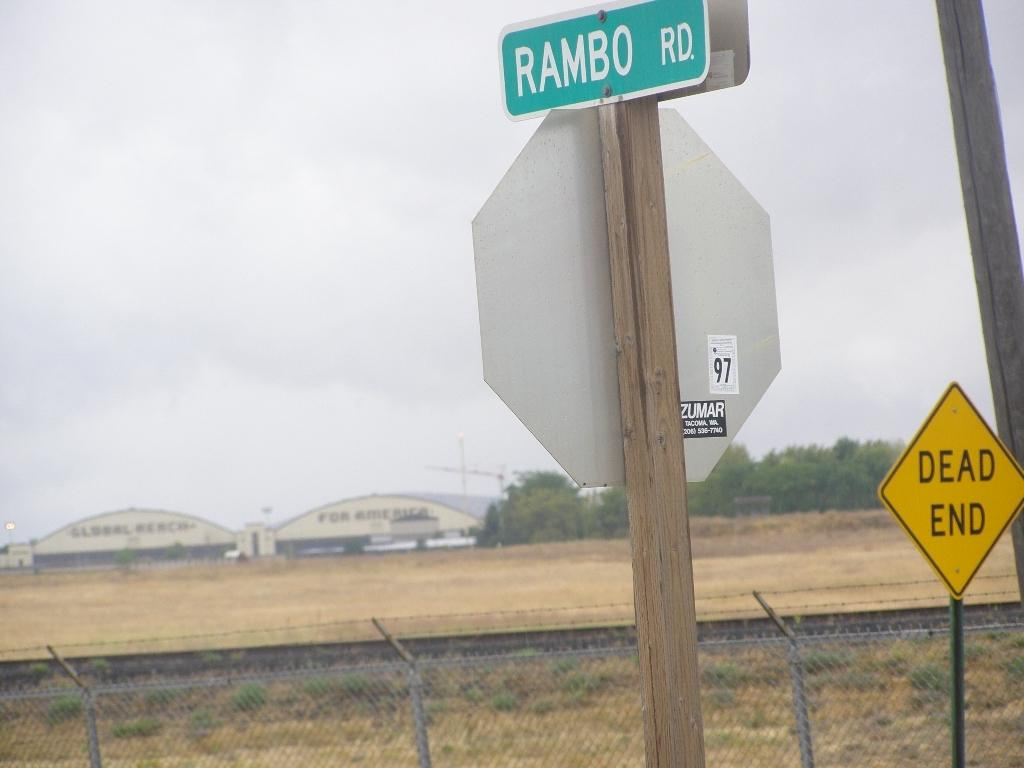Provide a one-sentence caption for the provided image. Near the road there are a couple of signs, one which indicates the street is Rambo Rd. 